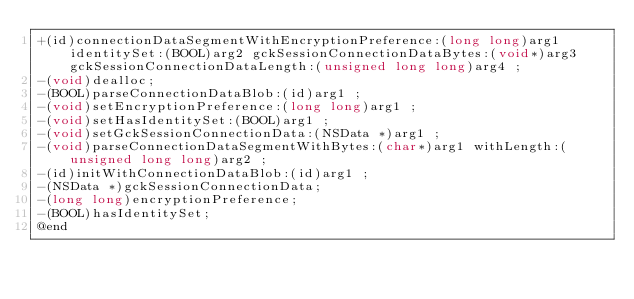Convert code to text. <code><loc_0><loc_0><loc_500><loc_500><_C_>+(id)connectionDataSegmentWithEncryptionPreference:(long long)arg1 identitySet:(BOOL)arg2 gckSessionConnectionDataBytes:(void*)arg3 gckSessionConnectionDataLength:(unsigned long long)arg4 ;
-(void)dealloc;
-(BOOL)parseConnectionDataBlob:(id)arg1 ;
-(void)setEncryptionPreference:(long long)arg1 ;
-(void)setHasIdentitySet:(BOOL)arg1 ;
-(void)setGckSessionConnectionData:(NSData *)arg1 ;
-(void)parseConnectionDataSegmentWithBytes:(char*)arg1 withLength:(unsigned long long)arg2 ;
-(id)initWithConnectionDataBlob:(id)arg1 ;
-(NSData *)gckSessionConnectionData;
-(long long)encryptionPreference;
-(BOOL)hasIdentitySet;
@end

</code> 